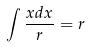<formula> <loc_0><loc_0><loc_500><loc_500>\int \frac { x d x } { r } = r</formula> 